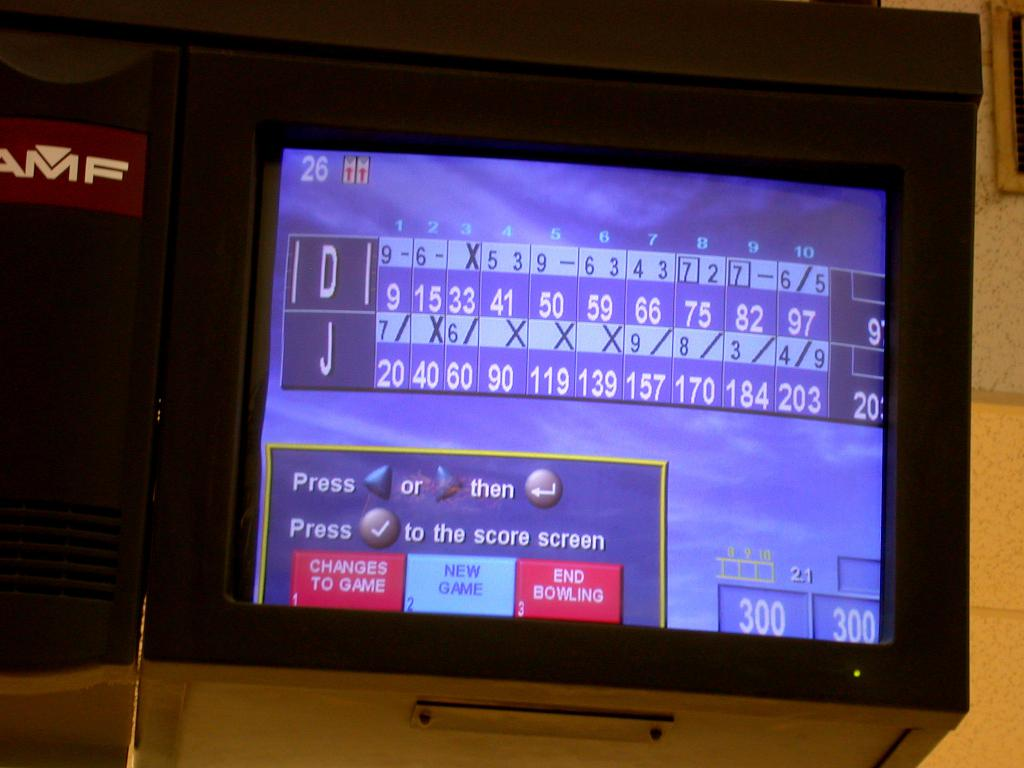What do the options at the bottom of this scoreboard imply? The options at the bottom of the scoreboard suggest functionalities for players to make changes to the game settings, view the score in more detail, start a new game, or end the current session, allowing for customized gameplay and management. 